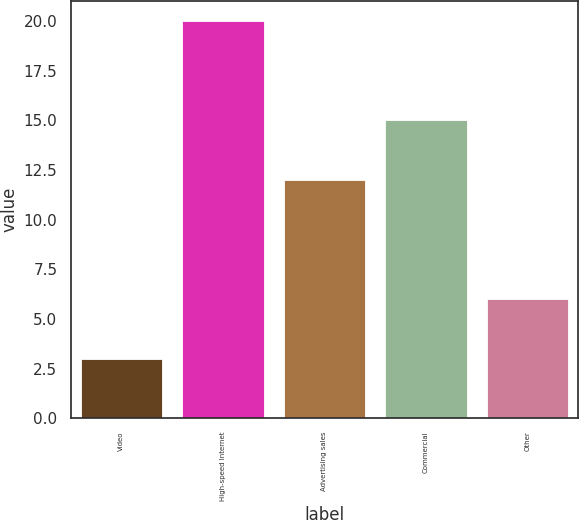<chart> <loc_0><loc_0><loc_500><loc_500><bar_chart><fcel>Video<fcel>High-speed Internet<fcel>Advertising sales<fcel>Commercial<fcel>Other<nl><fcel>3<fcel>20<fcel>12<fcel>15<fcel>6<nl></chart> 